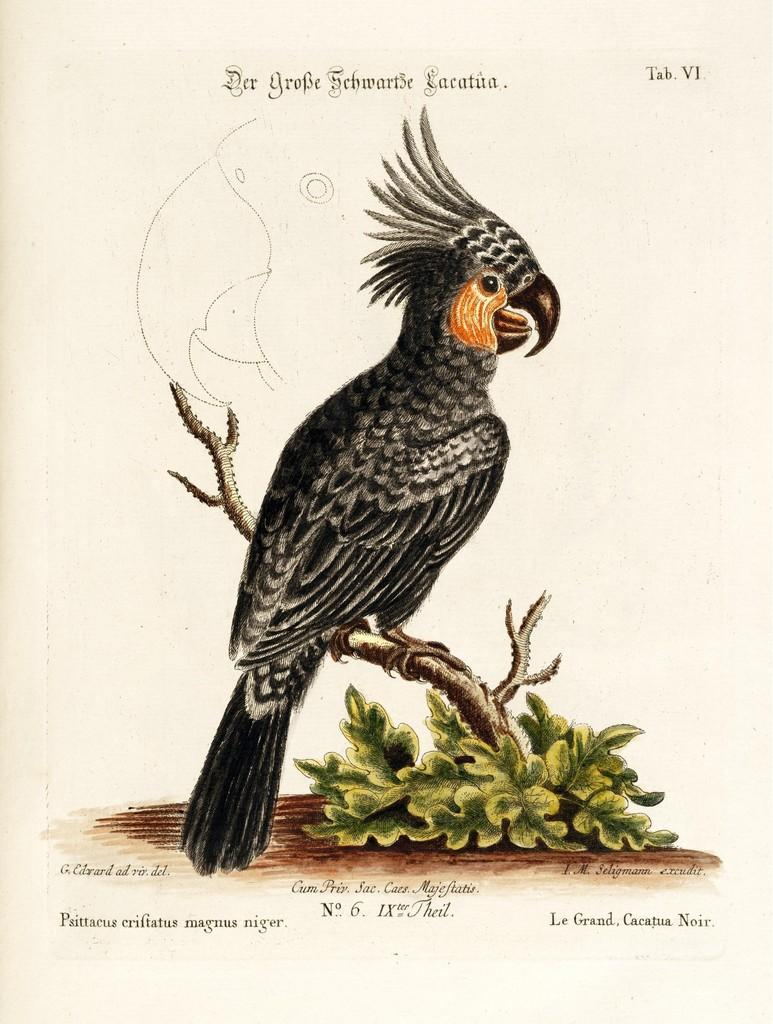What animal is in the picture? There is a parrot in the picture. Where is the parrot sitting? The parrot is sitting on a trunk. What can be seen on the ground in the picture? There are plants on the ground in the picture. What type of artwork is the image? The image is a drawing. What color are the parrot's feathers? The parrot has black feathers. Can you see any eggnog in the picture? There is no eggnog present in the image. Is the parrot showing any signs of a wound in the picture? There is no indication of a wound on the parrot in the image. 